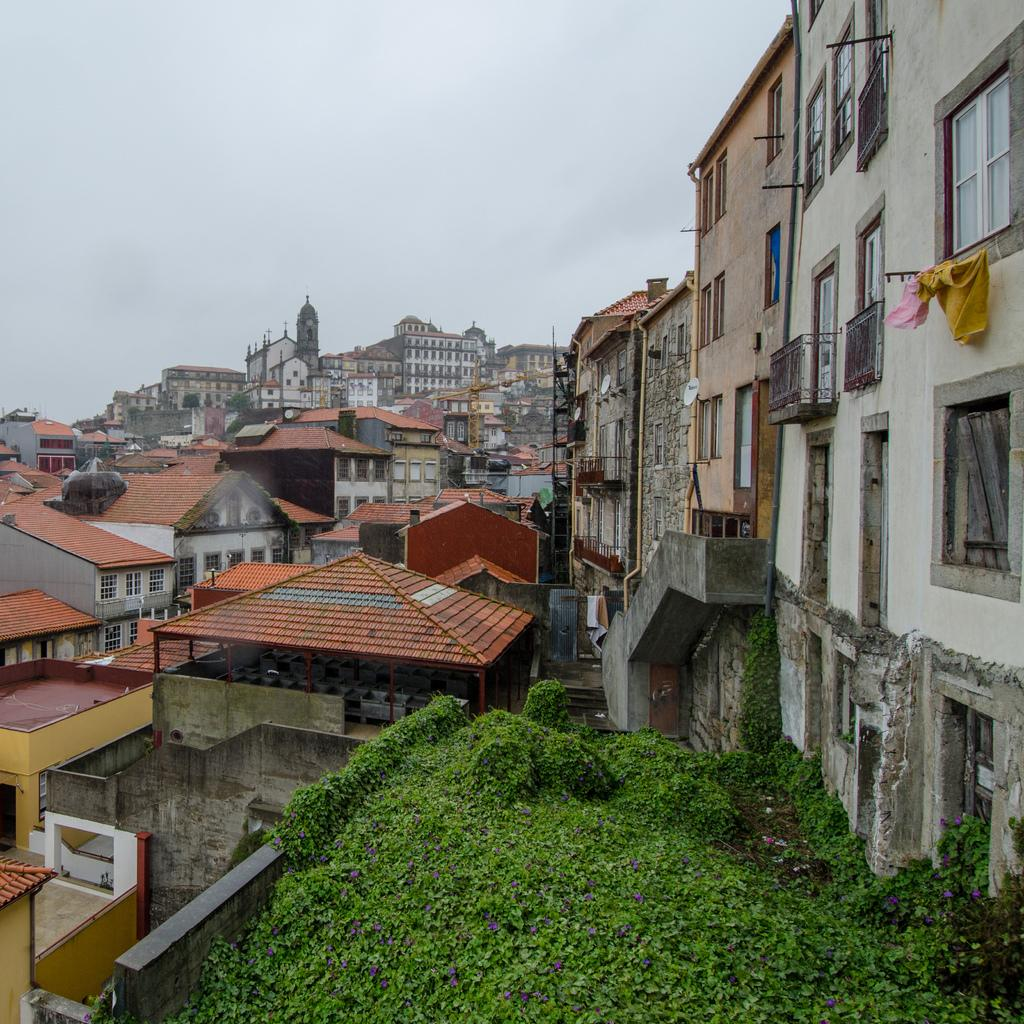What type of vegetation is present at the bottom of the image? There are plants at the bottom of the image. What structures can be seen in the middle of the image? There are buildings in the middle of the image. What is visible at the top of the image? The sky is visible at the top of the image. What hobbies are the plants at the bottom of the image engaged in? Plants do not have hobbies, as they are living organisms and not capable of engaging in hobbies. How does one pull the sky down from the top of the image? The sky cannot be pulled down from the top of the image, as it is a natural phenomenon and not a physical object that can be manipulated. 